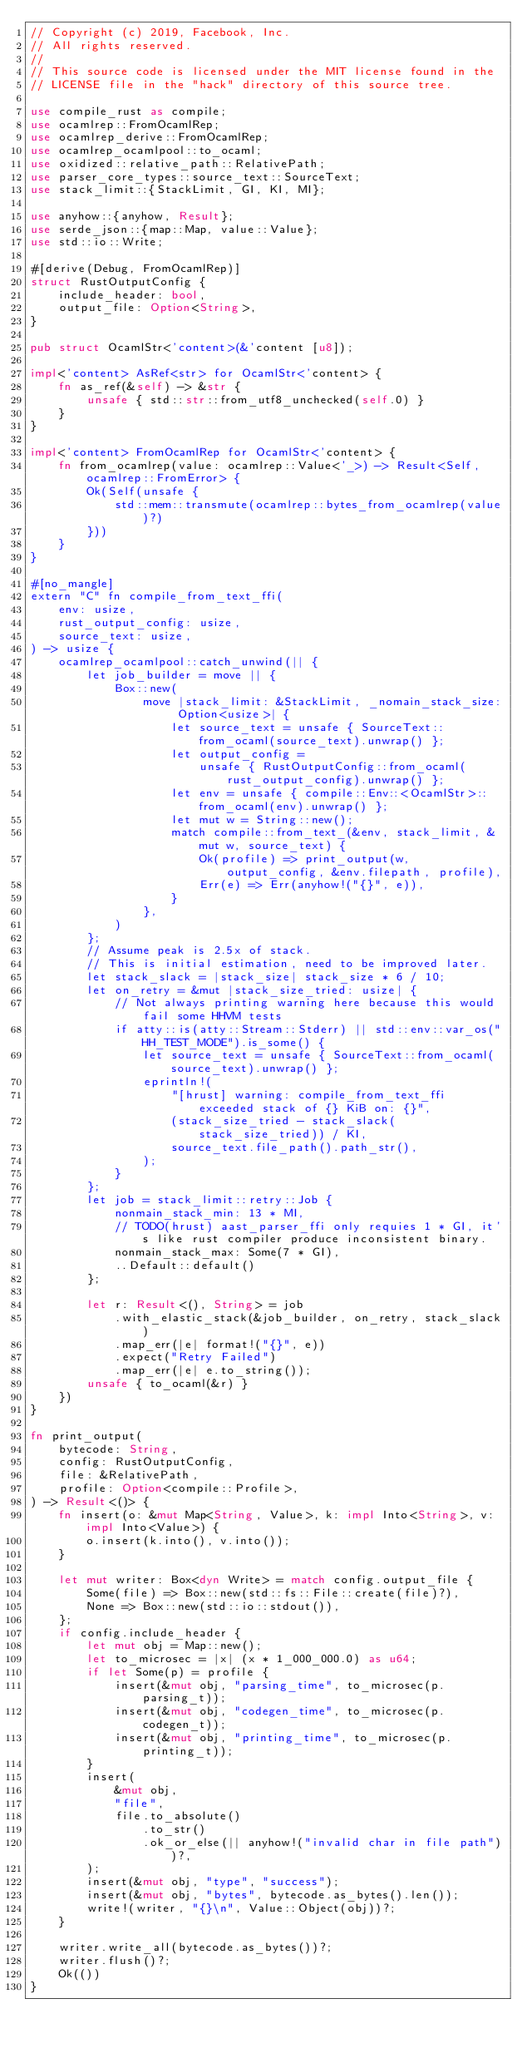<code> <loc_0><loc_0><loc_500><loc_500><_Rust_>// Copyright (c) 2019, Facebook, Inc.
// All rights reserved.
//
// This source code is licensed under the MIT license found in the
// LICENSE file in the "hack" directory of this source tree.

use compile_rust as compile;
use ocamlrep::FromOcamlRep;
use ocamlrep_derive::FromOcamlRep;
use ocamlrep_ocamlpool::to_ocaml;
use oxidized::relative_path::RelativePath;
use parser_core_types::source_text::SourceText;
use stack_limit::{StackLimit, GI, KI, MI};

use anyhow::{anyhow, Result};
use serde_json::{map::Map, value::Value};
use std::io::Write;

#[derive(Debug, FromOcamlRep)]
struct RustOutputConfig {
    include_header: bool,
    output_file: Option<String>,
}

pub struct OcamlStr<'content>(&'content [u8]);

impl<'content> AsRef<str> for OcamlStr<'content> {
    fn as_ref(&self) -> &str {
        unsafe { std::str::from_utf8_unchecked(self.0) }
    }
}

impl<'content> FromOcamlRep for OcamlStr<'content> {
    fn from_ocamlrep(value: ocamlrep::Value<'_>) -> Result<Self, ocamlrep::FromError> {
        Ok(Self(unsafe {
            std::mem::transmute(ocamlrep::bytes_from_ocamlrep(value)?)
        }))
    }
}

#[no_mangle]
extern "C" fn compile_from_text_ffi(
    env: usize,
    rust_output_config: usize,
    source_text: usize,
) -> usize {
    ocamlrep_ocamlpool::catch_unwind(|| {
        let job_builder = move || {
            Box::new(
                move |stack_limit: &StackLimit, _nomain_stack_size: Option<usize>| {
                    let source_text = unsafe { SourceText::from_ocaml(source_text).unwrap() };
                    let output_config =
                        unsafe { RustOutputConfig::from_ocaml(rust_output_config).unwrap() };
                    let env = unsafe { compile::Env::<OcamlStr>::from_ocaml(env).unwrap() };
                    let mut w = String::new();
                    match compile::from_text_(&env, stack_limit, &mut w, source_text) {
                        Ok(profile) => print_output(w, output_config, &env.filepath, profile),
                        Err(e) => Err(anyhow!("{}", e)),
                    }
                },
            )
        };
        // Assume peak is 2.5x of stack.
        // This is initial estimation, need to be improved later.
        let stack_slack = |stack_size| stack_size * 6 / 10;
        let on_retry = &mut |stack_size_tried: usize| {
            // Not always printing warning here because this would fail some HHVM tests
            if atty::is(atty::Stream::Stderr) || std::env::var_os("HH_TEST_MODE").is_some() {
                let source_text = unsafe { SourceText::from_ocaml(source_text).unwrap() };
                eprintln!(
                    "[hrust] warning: compile_from_text_ffi exceeded stack of {} KiB on: {}",
                    (stack_size_tried - stack_slack(stack_size_tried)) / KI,
                    source_text.file_path().path_str(),
                );
            }
        };
        let job = stack_limit::retry::Job {
            nonmain_stack_min: 13 * MI,
            // TODO(hrust) aast_parser_ffi only requies 1 * GI, it's like rust compiler produce inconsistent binary.
            nonmain_stack_max: Some(7 * GI),
            ..Default::default()
        };

        let r: Result<(), String> = job
            .with_elastic_stack(&job_builder, on_retry, stack_slack)
            .map_err(|e| format!("{}", e))
            .expect("Retry Failed")
            .map_err(|e| e.to_string());
        unsafe { to_ocaml(&r) }
    })
}

fn print_output(
    bytecode: String,
    config: RustOutputConfig,
    file: &RelativePath,
    profile: Option<compile::Profile>,
) -> Result<()> {
    fn insert(o: &mut Map<String, Value>, k: impl Into<String>, v: impl Into<Value>) {
        o.insert(k.into(), v.into());
    }

    let mut writer: Box<dyn Write> = match config.output_file {
        Some(file) => Box::new(std::fs::File::create(file)?),
        None => Box::new(std::io::stdout()),
    };
    if config.include_header {
        let mut obj = Map::new();
        let to_microsec = |x| (x * 1_000_000.0) as u64;
        if let Some(p) = profile {
            insert(&mut obj, "parsing_time", to_microsec(p.parsing_t));
            insert(&mut obj, "codegen_time", to_microsec(p.codegen_t));
            insert(&mut obj, "printing_time", to_microsec(p.printing_t));
        }
        insert(
            &mut obj,
            "file",
            file.to_absolute()
                .to_str()
                .ok_or_else(|| anyhow!("invalid char in file path"))?,
        );
        insert(&mut obj, "type", "success");
        insert(&mut obj, "bytes", bytecode.as_bytes().len());
        write!(writer, "{}\n", Value::Object(obj))?;
    }

    writer.write_all(bytecode.as_bytes())?;
    writer.flush()?;
    Ok(())
}
</code> 